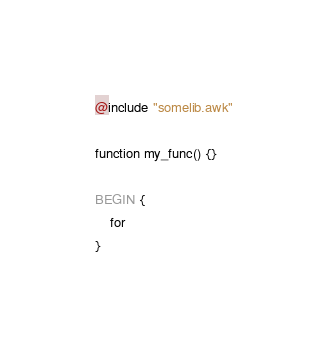<code> <loc_0><loc_0><loc_500><loc_500><_Awk_>@include "somelib.awk"

function my_func() {}

BEGIN {
    for
}
</code> 